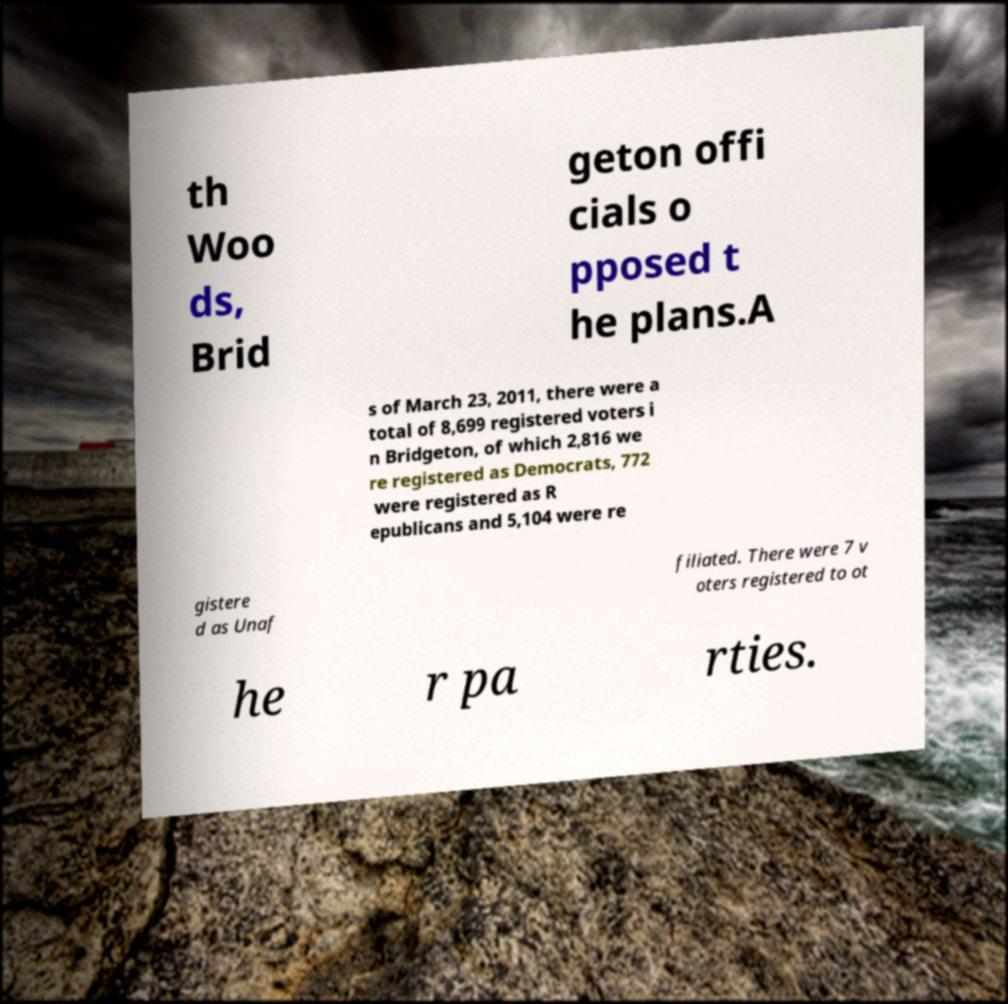There's text embedded in this image that I need extracted. Can you transcribe it verbatim? th Woo ds, Brid geton offi cials o pposed t he plans.A s of March 23, 2011, there were a total of 8,699 registered voters i n Bridgeton, of which 2,816 we re registered as Democrats, 772 were registered as R epublicans and 5,104 were re gistere d as Unaf filiated. There were 7 v oters registered to ot he r pa rties. 